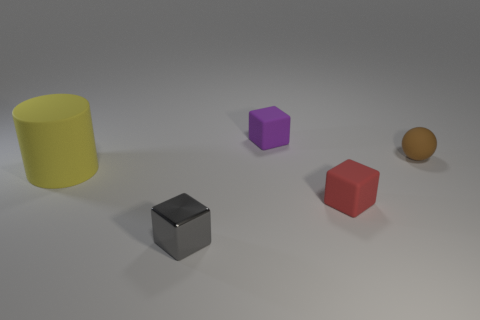What number of objects are either brown balls or tiny objects that are in front of the rubber sphere?
Offer a terse response. 3. How many other things are there of the same size as the red object?
Keep it short and to the point. 3. What is the material of the other small purple object that is the same shape as the tiny metallic thing?
Keep it short and to the point. Rubber. Are there more tiny gray shiny cubes behind the purple cube than small blocks?
Make the answer very short. No. Is there any other thing of the same color as the shiny cube?
Give a very brief answer. No. The red object that is made of the same material as the tiny purple cube is what shape?
Give a very brief answer. Cube. Is the block that is behind the rubber cylinder made of the same material as the gray cube?
Your answer should be very brief. No. There is a thing to the left of the tiny gray shiny object; does it have the same color as the tiny block behind the cylinder?
Offer a very short reply. No. How many things are both right of the small purple rubber thing and in front of the tiny brown rubber object?
Offer a very short reply. 1. What is the material of the brown object?
Your answer should be very brief. Rubber. 